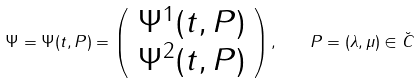Convert formula to latex. <formula><loc_0><loc_0><loc_500><loc_500>\Psi = \Psi ( t , P ) = \left ( \begin{array} { c } \Psi ^ { 1 } ( t , P ) \\ \Psi ^ { 2 } ( t , P ) \end{array} \right ) , \quad P = ( \lambda , \mu ) \in \breve { C }</formula> 